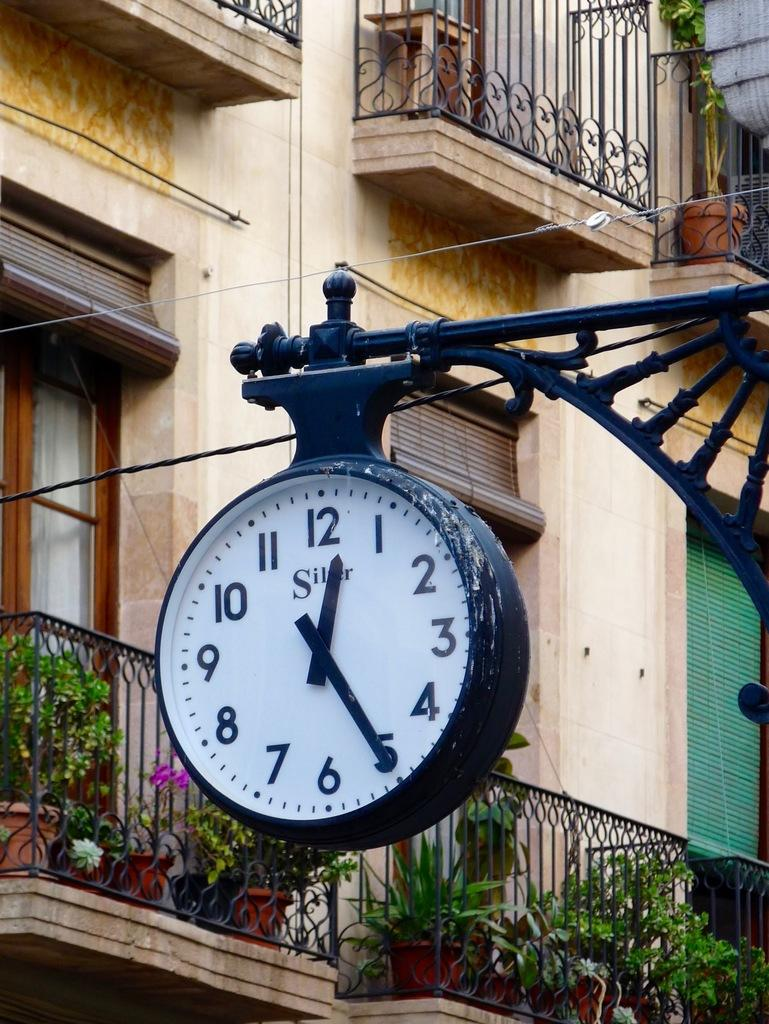<image>
Share a concise interpretation of the image provided. A black clock in a town showing 12:25. 